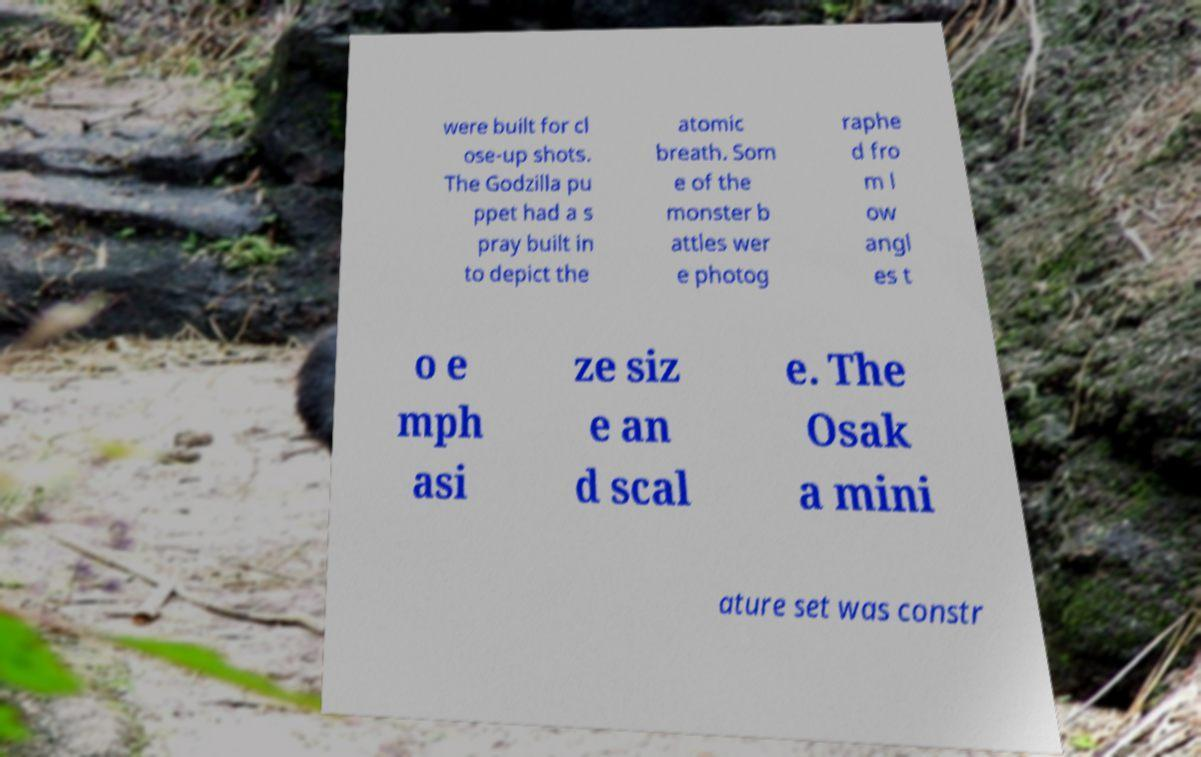What messages or text are displayed in this image? I need them in a readable, typed format. were built for cl ose-up shots. The Godzilla pu ppet had a s pray built in to depict the atomic breath. Som e of the monster b attles wer e photog raphe d fro m l ow angl es t o e mph asi ze siz e an d scal e. The Osak a mini ature set was constr 